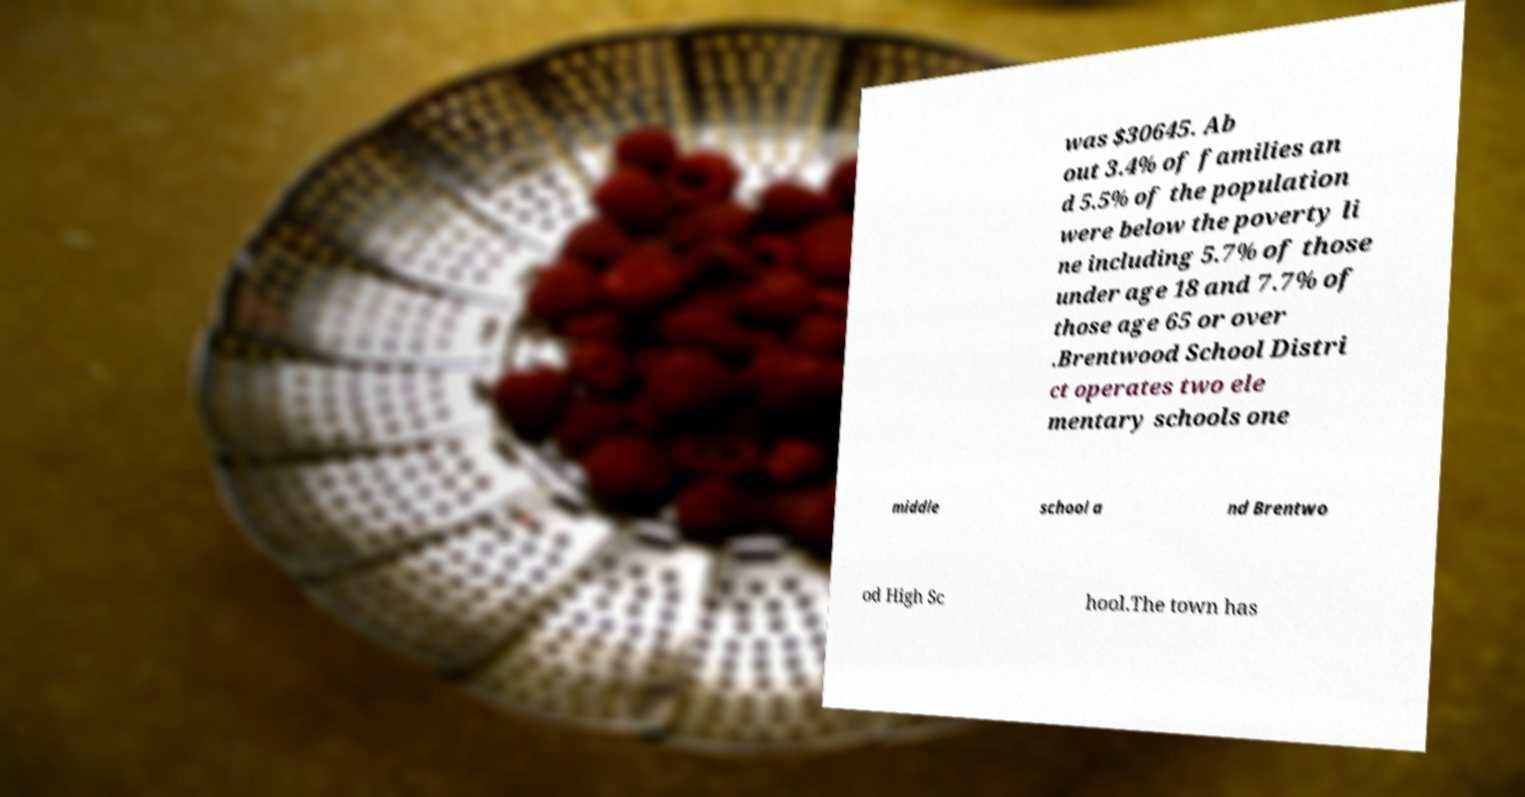I need the written content from this picture converted into text. Can you do that? was $30645. Ab out 3.4% of families an d 5.5% of the population were below the poverty li ne including 5.7% of those under age 18 and 7.7% of those age 65 or over .Brentwood School Distri ct operates two ele mentary schools one middle school a nd Brentwo od High Sc hool.The town has 